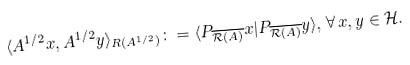<formula> <loc_0><loc_0><loc_500><loc_500>\langle A ^ { 1 / 2 } x , A ^ { 1 / 2 } y \rangle _ { R ( A ^ { 1 / 2 } ) } \colon = \langle P _ { \overline { \mathcal { R } ( A ) } } x | P _ { \overline { \mathcal { R } ( A ) } } y \rangle , \, \forall \, x , y \in \mathcal { H } .</formula> 